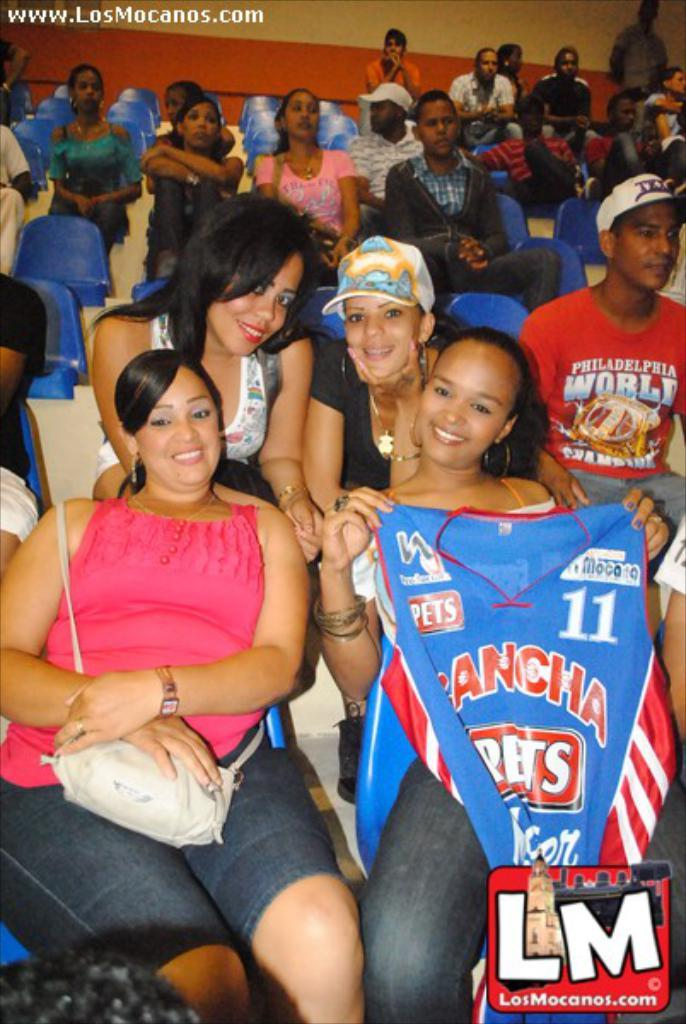<image>
Present a compact description of the photo's key features. Women on the right holding up a shirt that says Cancha # 11. 